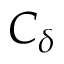<formula> <loc_0><loc_0><loc_500><loc_500>C _ { \delta }</formula> 